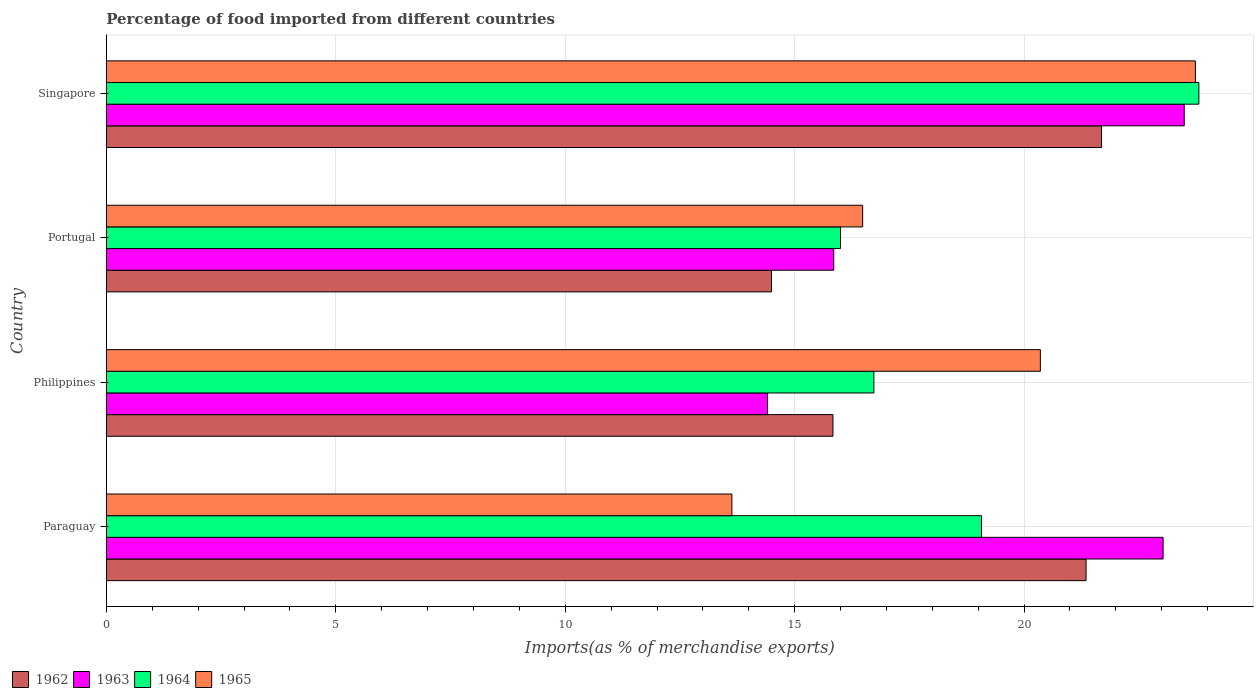How many different coloured bars are there?
Offer a very short reply. 4. How many groups of bars are there?
Offer a very short reply. 4. Are the number of bars on each tick of the Y-axis equal?
Give a very brief answer. Yes. How many bars are there on the 1st tick from the top?
Keep it short and to the point. 4. What is the label of the 4th group of bars from the top?
Give a very brief answer. Paraguay. In how many cases, is the number of bars for a given country not equal to the number of legend labels?
Give a very brief answer. 0. What is the percentage of imports to different countries in 1965 in Philippines?
Keep it short and to the point. 20.35. Across all countries, what is the maximum percentage of imports to different countries in 1965?
Provide a succinct answer. 23.73. Across all countries, what is the minimum percentage of imports to different countries in 1965?
Keep it short and to the point. 13.63. In which country was the percentage of imports to different countries in 1962 maximum?
Your response must be concise. Singapore. In which country was the percentage of imports to different countries in 1965 minimum?
Make the answer very short. Paraguay. What is the total percentage of imports to different countries in 1962 in the graph?
Give a very brief answer. 73.37. What is the difference between the percentage of imports to different countries in 1963 in Paraguay and that in Portugal?
Provide a succinct answer. 7.18. What is the difference between the percentage of imports to different countries in 1965 in Paraguay and the percentage of imports to different countries in 1964 in Philippines?
Provide a succinct answer. -3.09. What is the average percentage of imports to different countries in 1962 per country?
Give a very brief answer. 18.34. What is the difference between the percentage of imports to different countries in 1964 and percentage of imports to different countries in 1962 in Singapore?
Ensure brevity in your answer.  2.12. In how many countries, is the percentage of imports to different countries in 1964 greater than 10 %?
Keep it short and to the point. 4. What is the ratio of the percentage of imports to different countries in 1963 in Portugal to that in Singapore?
Provide a short and direct response. 0.67. Is the difference between the percentage of imports to different countries in 1964 in Philippines and Portugal greater than the difference between the percentage of imports to different countries in 1962 in Philippines and Portugal?
Provide a short and direct response. No. What is the difference between the highest and the second highest percentage of imports to different countries in 1962?
Ensure brevity in your answer.  0.34. What is the difference between the highest and the lowest percentage of imports to different countries in 1963?
Make the answer very short. 9.08. In how many countries, is the percentage of imports to different countries in 1963 greater than the average percentage of imports to different countries in 1963 taken over all countries?
Offer a very short reply. 2. Is the sum of the percentage of imports to different countries in 1965 in Paraguay and Portugal greater than the maximum percentage of imports to different countries in 1964 across all countries?
Ensure brevity in your answer.  Yes. What does the 1st bar from the bottom in Singapore represents?
Your response must be concise. 1962. Is it the case that in every country, the sum of the percentage of imports to different countries in 1965 and percentage of imports to different countries in 1962 is greater than the percentage of imports to different countries in 1963?
Give a very brief answer. Yes. Where does the legend appear in the graph?
Offer a very short reply. Bottom left. What is the title of the graph?
Make the answer very short. Percentage of food imported from different countries. Does "1990" appear as one of the legend labels in the graph?
Offer a terse response. No. What is the label or title of the X-axis?
Provide a succinct answer. Imports(as % of merchandise exports). What is the Imports(as % of merchandise exports) of 1962 in Paraguay?
Your answer should be very brief. 21.35. What is the Imports(as % of merchandise exports) of 1963 in Paraguay?
Provide a succinct answer. 23.03. What is the Imports(as % of merchandise exports) of 1964 in Paraguay?
Your answer should be very brief. 19.07. What is the Imports(as % of merchandise exports) in 1965 in Paraguay?
Provide a short and direct response. 13.63. What is the Imports(as % of merchandise exports) in 1962 in Philippines?
Offer a terse response. 15.83. What is the Imports(as % of merchandise exports) in 1963 in Philippines?
Give a very brief answer. 14.41. What is the Imports(as % of merchandise exports) of 1964 in Philippines?
Ensure brevity in your answer.  16.73. What is the Imports(as % of merchandise exports) of 1965 in Philippines?
Provide a short and direct response. 20.35. What is the Imports(as % of merchandise exports) of 1962 in Portugal?
Keep it short and to the point. 14.49. What is the Imports(as % of merchandise exports) in 1963 in Portugal?
Give a very brief answer. 15.85. What is the Imports(as % of merchandise exports) in 1964 in Portugal?
Offer a very short reply. 16. What is the Imports(as % of merchandise exports) in 1965 in Portugal?
Provide a short and direct response. 16.48. What is the Imports(as % of merchandise exports) of 1962 in Singapore?
Your answer should be very brief. 21.69. What is the Imports(as % of merchandise exports) in 1963 in Singapore?
Give a very brief answer. 23.49. What is the Imports(as % of merchandise exports) in 1964 in Singapore?
Your answer should be very brief. 23.81. What is the Imports(as % of merchandise exports) in 1965 in Singapore?
Your response must be concise. 23.73. Across all countries, what is the maximum Imports(as % of merchandise exports) in 1962?
Your answer should be very brief. 21.69. Across all countries, what is the maximum Imports(as % of merchandise exports) of 1963?
Keep it short and to the point. 23.49. Across all countries, what is the maximum Imports(as % of merchandise exports) of 1964?
Offer a very short reply. 23.81. Across all countries, what is the maximum Imports(as % of merchandise exports) of 1965?
Keep it short and to the point. 23.73. Across all countries, what is the minimum Imports(as % of merchandise exports) of 1962?
Provide a short and direct response. 14.49. Across all countries, what is the minimum Imports(as % of merchandise exports) in 1963?
Your answer should be compact. 14.41. Across all countries, what is the minimum Imports(as % of merchandise exports) in 1964?
Give a very brief answer. 16. Across all countries, what is the minimum Imports(as % of merchandise exports) in 1965?
Ensure brevity in your answer.  13.63. What is the total Imports(as % of merchandise exports) of 1962 in the graph?
Your response must be concise. 73.37. What is the total Imports(as % of merchandise exports) in 1963 in the graph?
Provide a short and direct response. 76.78. What is the total Imports(as % of merchandise exports) in 1964 in the graph?
Ensure brevity in your answer.  75.61. What is the total Imports(as % of merchandise exports) of 1965 in the graph?
Offer a very short reply. 74.2. What is the difference between the Imports(as % of merchandise exports) in 1962 in Paraguay and that in Philippines?
Your answer should be compact. 5.52. What is the difference between the Imports(as % of merchandise exports) of 1963 in Paraguay and that in Philippines?
Your response must be concise. 8.62. What is the difference between the Imports(as % of merchandise exports) of 1964 in Paraguay and that in Philippines?
Give a very brief answer. 2.35. What is the difference between the Imports(as % of merchandise exports) of 1965 in Paraguay and that in Philippines?
Make the answer very short. -6.72. What is the difference between the Imports(as % of merchandise exports) in 1962 in Paraguay and that in Portugal?
Give a very brief answer. 6.86. What is the difference between the Imports(as % of merchandise exports) in 1963 in Paraguay and that in Portugal?
Give a very brief answer. 7.18. What is the difference between the Imports(as % of merchandise exports) in 1964 in Paraguay and that in Portugal?
Keep it short and to the point. 3.07. What is the difference between the Imports(as % of merchandise exports) in 1965 in Paraguay and that in Portugal?
Provide a succinct answer. -2.85. What is the difference between the Imports(as % of merchandise exports) of 1962 in Paraguay and that in Singapore?
Provide a succinct answer. -0.34. What is the difference between the Imports(as % of merchandise exports) in 1963 in Paraguay and that in Singapore?
Make the answer very short. -0.46. What is the difference between the Imports(as % of merchandise exports) of 1964 in Paraguay and that in Singapore?
Your answer should be very brief. -4.74. What is the difference between the Imports(as % of merchandise exports) in 1965 in Paraguay and that in Singapore?
Keep it short and to the point. -10.1. What is the difference between the Imports(as % of merchandise exports) in 1962 in Philippines and that in Portugal?
Provide a short and direct response. 1.34. What is the difference between the Imports(as % of merchandise exports) of 1963 in Philippines and that in Portugal?
Ensure brevity in your answer.  -1.44. What is the difference between the Imports(as % of merchandise exports) in 1964 in Philippines and that in Portugal?
Provide a short and direct response. 0.73. What is the difference between the Imports(as % of merchandise exports) of 1965 in Philippines and that in Portugal?
Offer a very short reply. 3.87. What is the difference between the Imports(as % of merchandise exports) of 1962 in Philippines and that in Singapore?
Offer a terse response. -5.85. What is the difference between the Imports(as % of merchandise exports) in 1963 in Philippines and that in Singapore?
Your answer should be compact. -9.08. What is the difference between the Imports(as % of merchandise exports) of 1964 in Philippines and that in Singapore?
Your response must be concise. -7.08. What is the difference between the Imports(as % of merchandise exports) in 1965 in Philippines and that in Singapore?
Your answer should be very brief. -3.38. What is the difference between the Imports(as % of merchandise exports) of 1962 in Portugal and that in Singapore?
Provide a short and direct response. -7.19. What is the difference between the Imports(as % of merchandise exports) in 1963 in Portugal and that in Singapore?
Offer a very short reply. -7.64. What is the difference between the Imports(as % of merchandise exports) in 1964 in Portugal and that in Singapore?
Your answer should be very brief. -7.81. What is the difference between the Imports(as % of merchandise exports) of 1965 in Portugal and that in Singapore?
Make the answer very short. -7.25. What is the difference between the Imports(as % of merchandise exports) in 1962 in Paraguay and the Imports(as % of merchandise exports) in 1963 in Philippines?
Your answer should be very brief. 6.94. What is the difference between the Imports(as % of merchandise exports) in 1962 in Paraguay and the Imports(as % of merchandise exports) in 1964 in Philippines?
Ensure brevity in your answer.  4.62. What is the difference between the Imports(as % of merchandise exports) of 1962 in Paraguay and the Imports(as % of merchandise exports) of 1965 in Philippines?
Your response must be concise. 1. What is the difference between the Imports(as % of merchandise exports) of 1963 in Paraguay and the Imports(as % of merchandise exports) of 1964 in Philippines?
Your answer should be compact. 6.3. What is the difference between the Imports(as % of merchandise exports) in 1963 in Paraguay and the Imports(as % of merchandise exports) in 1965 in Philippines?
Provide a succinct answer. 2.67. What is the difference between the Imports(as % of merchandise exports) in 1964 in Paraguay and the Imports(as % of merchandise exports) in 1965 in Philippines?
Make the answer very short. -1.28. What is the difference between the Imports(as % of merchandise exports) in 1962 in Paraguay and the Imports(as % of merchandise exports) in 1963 in Portugal?
Make the answer very short. 5.5. What is the difference between the Imports(as % of merchandise exports) in 1962 in Paraguay and the Imports(as % of merchandise exports) in 1964 in Portugal?
Ensure brevity in your answer.  5.35. What is the difference between the Imports(as % of merchandise exports) in 1962 in Paraguay and the Imports(as % of merchandise exports) in 1965 in Portugal?
Give a very brief answer. 4.87. What is the difference between the Imports(as % of merchandise exports) in 1963 in Paraguay and the Imports(as % of merchandise exports) in 1964 in Portugal?
Your answer should be compact. 7.03. What is the difference between the Imports(as % of merchandise exports) in 1963 in Paraguay and the Imports(as % of merchandise exports) in 1965 in Portugal?
Your answer should be very brief. 6.55. What is the difference between the Imports(as % of merchandise exports) of 1964 in Paraguay and the Imports(as % of merchandise exports) of 1965 in Portugal?
Your response must be concise. 2.59. What is the difference between the Imports(as % of merchandise exports) of 1962 in Paraguay and the Imports(as % of merchandise exports) of 1963 in Singapore?
Your answer should be compact. -2.14. What is the difference between the Imports(as % of merchandise exports) in 1962 in Paraguay and the Imports(as % of merchandise exports) in 1964 in Singapore?
Your answer should be very brief. -2.46. What is the difference between the Imports(as % of merchandise exports) in 1962 in Paraguay and the Imports(as % of merchandise exports) in 1965 in Singapore?
Offer a terse response. -2.38. What is the difference between the Imports(as % of merchandise exports) in 1963 in Paraguay and the Imports(as % of merchandise exports) in 1964 in Singapore?
Provide a short and direct response. -0.78. What is the difference between the Imports(as % of merchandise exports) of 1963 in Paraguay and the Imports(as % of merchandise exports) of 1965 in Singapore?
Ensure brevity in your answer.  -0.7. What is the difference between the Imports(as % of merchandise exports) of 1964 in Paraguay and the Imports(as % of merchandise exports) of 1965 in Singapore?
Keep it short and to the point. -4.66. What is the difference between the Imports(as % of merchandise exports) in 1962 in Philippines and the Imports(as % of merchandise exports) in 1963 in Portugal?
Provide a succinct answer. -0.02. What is the difference between the Imports(as % of merchandise exports) of 1962 in Philippines and the Imports(as % of merchandise exports) of 1964 in Portugal?
Offer a very short reply. -0.16. What is the difference between the Imports(as % of merchandise exports) of 1962 in Philippines and the Imports(as % of merchandise exports) of 1965 in Portugal?
Your response must be concise. -0.65. What is the difference between the Imports(as % of merchandise exports) in 1963 in Philippines and the Imports(as % of merchandise exports) in 1964 in Portugal?
Provide a short and direct response. -1.59. What is the difference between the Imports(as % of merchandise exports) of 1963 in Philippines and the Imports(as % of merchandise exports) of 1965 in Portugal?
Provide a short and direct response. -2.07. What is the difference between the Imports(as % of merchandise exports) of 1964 in Philippines and the Imports(as % of merchandise exports) of 1965 in Portugal?
Keep it short and to the point. 0.24. What is the difference between the Imports(as % of merchandise exports) of 1962 in Philippines and the Imports(as % of merchandise exports) of 1963 in Singapore?
Your response must be concise. -7.65. What is the difference between the Imports(as % of merchandise exports) of 1962 in Philippines and the Imports(as % of merchandise exports) of 1964 in Singapore?
Your answer should be very brief. -7.97. What is the difference between the Imports(as % of merchandise exports) in 1962 in Philippines and the Imports(as % of merchandise exports) in 1965 in Singapore?
Give a very brief answer. -7.9. What is the difference between the Imports(as % of merchandise exports) in 1963 in Philippines and the Imports(as % of merchandise exports) in 1964 in Singapore?
Provide a succinct answer. -9.4. What is the difference between the Imports(as % of merchandise exports) of 1963 in Philippines and the Imports(as % of merchandise exports) of 1965 in Singapore?
Your answer should be compact. -9.32. What is the difference between the Imports(as % of merchandise exports) of 1964 in Philippines and the Imports(as % of merchandise exports) of 1965 in Singapore?
Make the answer very short. -7.01. What is the difference between the Imports(as % of merchandise exports) in 1962 in Portugal and the Imports(as % of merchandise exports) in 1963 in Singapore?
Provide a short and direct response. -8.99. What is the difference between the Imports(as % of merchandise exports) of 1962 in Portugal and the Imports(as % of merchandise exports) of 1964 in Singapore?
Make the answer very short. -9.31. What is the difference between the Imports(as % of merchandise exports) in 1962 in Portugal and the Imports(as % of merchandise exports) in 1965 in Singapore?
Keep it short and to the point. -9.24. What is the difference between the Imports(as % of merchandise exports) in 1963 in Portugal and the Imports(as % of merchandise exports) in 1964 in Singapore?
Provide a short and direct response. -7.96. What is the difference between the Imports(as % of merchandise exports) in 1963 in Portugal and the Imports(as % of merchandise exports) in 1965 in Singapore?
Give a very brief answer. -7.88. What is the difference between the Imports(as % of merchandise exports) of 1964 in Portugal and the Imports(as % of merchandise exports) of 1965 in Singapore?
Make the answer very short. -7.73. What is the average Imports(as % of merchandise exports) of 1962 per country?
Provide a short and direct response. 18.34. What is the average Imports(as % of merchandise exports) of 1963 per country?
Provide a short and direct response. 19.2. What is the average Imports(as % of merchandise exports) of 1964 per country?
Your answer should be compact. 18.9. What is the average Imports(as % of merchandise exports) of 1965 per country?
Your response must be concise. 18.55. What is the difference between the Imports(as % of merchandise exports) in 1962 and Imports(as % of merchandise exports) in 1963 in Paraguay?
Your answer should be compact. -1.68. What is the difference between the Imports(as % of merchandise exports) of 1962 and Imports(as % of merchandise exports) of 1964 in Paraguay?
Provide a succinct answer. 2.28. What is the difference between the Imports(as % of merchandise exports) in 1962 and Imports(as % of merchandise exports) in 1965 in Paraguay?
Offer a very short reply. 7.72. What is the difference between the Imports(as % of merchandise exports) of 1963 and Imports(as % of merchandise exports) of 1964 in Paraguay?
Provide a short and direct response. 3.96. What is the difference between the Imports(as % of merchandise exports) of 1963 and Imports(as % of merchandise exports) of 1965 in Paraguay?
Your answer should be compact. 9.4. What is the difference between the Imports(as % of merchandise exports) of 1964 and Imports(as % of merchandise exports) of 1965 in Paraguay?
Keep it short and to the point. 5.44. What is the difference between the Imports(as % of merchandise exports) of 1962 and Imports(as % of merchandise exports) of 1963 in Philippines?
Offer a very short reply. 1.43. What is the difference between the Imports(as % of merchandise exports) of 1962 and Imports(as % of merchandise exports) of 1964 in Philippines?
Your answer should be very brief. -0.89. What is the difference between the Imports(as % of merchandise exports) of 1962 and Imports(as % of merchandise exports) of 1965 in Philippines?
Offer a very short reply. -4.52. What is the difference between the Imports(as % of merchandise exports) of 1963 and Imports(as % of merchandise exports) of 1964 in Philippines?
Your answer should be very brief. -2.32. What is the difference between the Imports(as % of merchandise exports) in 1963 and Imports(as % of merchandise exports) in 1965 in Philippines?
Ensure brevity in your answer.  -5.94. What is the difference between the Imports(as % of merchandise exports) of 1964 and Imports(as % of merchandise exports) of 1965 in Philippines?
Offer a very short reply. -3.63. What is the difference between the Imports(as % of merchandise exports) of 1962 and Imports(as % of merchandise exports) of 1963 in Portugal?
Make the answer very short. -1.36. What is the difference between the Imports(as % of merchandise exports) of 1962 and Imports(as % of merchandise exports) of 1964 in Portugal?
Ensure brevity in your answer.  -1.5. What is the difference between the Imports(as % of merchandise exports) in 1962 and Imports(as % of merchandise exports) in 1965 in Portugal?
Make the answer very short. -1.99. What is the difference between the Imports(as % of merchandise exports) in 1963 and Imports(as % of merchandise exports) in 1964 in Portugal?
Your response must be concise. -0.15. What is the difference between the Imports(as % of merchandise exports) in 1963 and Imports(as % of merchandise exports) in 1965 in Portugal?
Offer a terse response. -0.63. What is the difference between the Imports(as % of merchandise exports) in 1964 and Imports(as % of merchandise exports) in 1965 in Portugal?
Provide a succinct answer. -0.48. What is the difference between the Imports(as % of merchandise exports) in 1962 and Imports(as % of merchandise exports) in 1963 in Singapore?
Make the answer very short. -1.8. What is the difference between the Imports(as % of merchandise exports) in 1962 and Imports(as % of merchandise exports) in 1964 in Singapore?
Offer a very short reply. -2.12. What is the difference between the Imports(as % of merchandise exports) in 1962 and Imports(as % of merchandise exports) in 1965 in Singapore?
Ensure brevity in your answer.  -2.04. What is the difference between the Imports(as % of merchandise exports) of 1963 and Imports(as % of merchandise exports) of 1964 in Singapore?
Offer a terse response. -0.32. What is the difference between the Imports(as % of merchandise exports) in 1963 and Imports(as % of merchandise exports) in 1965 in Singapore?
Give a very brief answer. -0.24. What is the difference between the Imports(as % of merchandise exports) of 1964 and Imports(as % of merchandise exports) of 1965 in Singapore?
Provide a succinct answer. 0.08. What is the ratio of the Imports(as % of merchandise exports) of 1962 in Paraguay to that in Philippines?
Your answer should be very brief. 1.35. What is the ratio of the Imports(as % of merchandise exports) in 1963 in Paraguay to that in Philippines?
Your answer should be compact. 1.6. What is the ratio of the Imports(as % of merchandise exports) of 1964 in Paraguay to that in Philippines?
Your answer should be compact. 1.14. What is the ratio of the Imports(as % of merchandise exports) in 1965 in Paraguay to that in Philippines?
Your answer should be very brief. 0.67. What is the ratio of the Imports(as % of merchandise exports) of 1962 in Paraguay to that in Portugal?
Offer a very short reply. 1.47. What is the ratio of the Imports(as % of merchandise exports) in 1963 in Paraguay to that in Portugal?
Keep it short and to the point. 1.45. What is the ratio of the Imports(as % of merchandise exports) of 1964 in Paraguay to that in Portugal?
Offer a terse response. 1.19. What is the ratio of the Imports(as % of merchandise exports) of 1965 in Paraguay to that in Portugal?
Make the answer very short. 0.83. What is the ratio of the Imports(as % of merchandise exports) of 1962 in Paraguay to that in Singapore?
Your response must be concise. 0.98. What is the ratio of the Imports(as % of merchandise exports) of 1963 in Paraguay to that in Singapore?
Provide a short and direct response. 0.98. What is the ratio of the Imports(as % of merchandise exports) of 1964 in Paraguay to that in Singapore?
Provide a short and direct response. 0.8. What is the ratio of the Imports(as % of merchandise exports) in 1965 in Paraguay to that in Singapore?
Give a very brief answer. 0.57. What is the ratio of the Imports(as % of merchandise exports) in 1962 in Philippines to that in Portugal?
Provide a succinct answer. 1.09. What is the ratio of the Imports(as % of merchandise exports) of 1963 in Philippines to that in Portugal?
Your answer should be compact. 0.91. What is the ratio of the Imports(as % of merchandise exports) of 1964 in Philippines to that in Portugal?
Provide a short and direct response. 1.05. What is the ratio of the Imports(as % of merchandise exports) of 1965 in Philippines to that in Portugal?
Your answer should be compact. 1.24. What is the ratio of the Imports(as % of merchandise exports) of 1962 in Philippines to that in Singapore?
Your answer should be compact. 0.73. What is the ratio of the Imports(as % of merchandise exports) in 1963 in Philippines to that in Singapore?
Your response must be concise. 0.61. What is the ratio of the Imports(as % of merchandise exports) in 1964 in Philippines to that in Singapore?
Make the answer very short. 0.7. What is the ratio of the Imports(as % of merchandise exports) in 1965 in Philippines to that in Singapore?
Keep it short and to the point. 0.86. What is the ratio of the Imports(as % of merchandise exports) of 1962 in Portugal to that in Singapore?
Your answer should be very brief. 0.67. What is the ratio of the Imports(as % of merchandise exports) of 1963 in Portugal to that in Singapore?
Provide a succinct answer. 0.67. What is the ratio of the Imports(as % of merchandise exports) in 1964 in Portugal to that in Singapore?
Your response must be concise. 0.67. What is the ratio of the Imports(as % of merchandise exports) in 1965 in Portugal to that in Singapore?
Make the answer very short. 0.69. What is the difference between the highest and the second highest Imports(as % of merchandise exports) in 1962?
Provide a succinct answer. 0.34. What is the difference between the highest and the second highest Imports(as % of merchandise exports) in 1963?
Provide a short and direct response. 0.46. What is the difference between the highest and the second highest Imports(as % of merchandise exports) in 1964?
Provide a succinct answer. 4.74. What is the difference between the highest and the second highest Imports(as % of merchandise exports) of 1965?
Provide a short and direct response. 3.38. What is the difference between the highest and the lowest Imports(as % of merchandise exports) in 1962?
Make the answer very short. 7.19. What is the difference between the highest and the lowest Imports(as % of merchandise exports) in 1963?
Your answer should be compact. 9.08. What is the difference between the highest and the lowest Imports(as % of merchandise exports) of 1964?
Give a very brief answer. 7.81. What is the difference between the highest and the lowest Imports(as % of merchandise exports) in 1965?
Offer a very short reply. 10.1. 